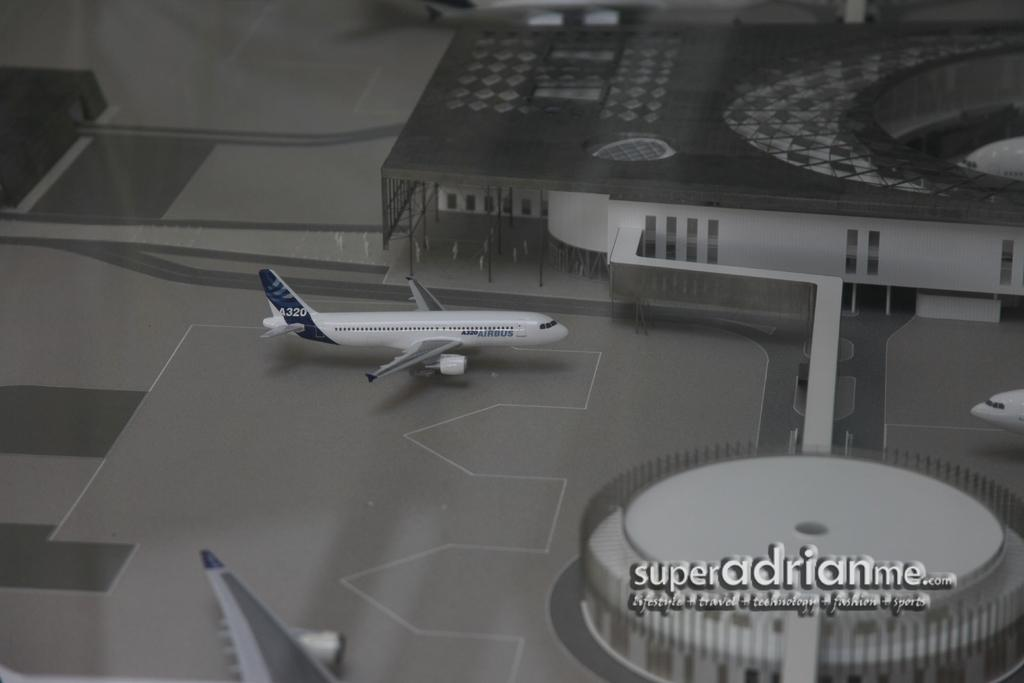What objects are on the floor in the image? There are four airplanes on the floor in the image. What type of barrier can be seen in the image? There is a fence visible in the image. What type of design element is present in the image? A logo is present in the image. What type of written information is visible in the image? Text is visible in the image. What type of structures can be seen in the image? There are buildings in the image. What can be inferred about the image based on the provided facts? The image appears to be an edited photo. Where is the lake located in the image? There is no lake present in the image. How many rabbits can be seen in the image? There are no rabbits present in the image. 